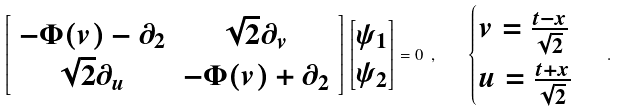<formula> <loc_0><loc_0><loc_500><loc_500>\left [ { \begin{array} { c c } - \Phi ( v ) - \partial _ { 2 } & \sqrt { 2 } \partial _ { v } \\ \sqrt { 2 } \partial _ { u } & - \Phi ( v ) + \partial _ { 2 } \\ \end{array} } \right ] \begin{bmatrix} \psi _ { 1 } \\ \psi _ { 2 } \end{bmatrix} = 0 \ , \quad \begin{cases} v = \frac { t - x } { \sqrt { 2 } } \\ u = \frac { t + x } { \sqrt { 2 } } \end{cases} .</formula> 